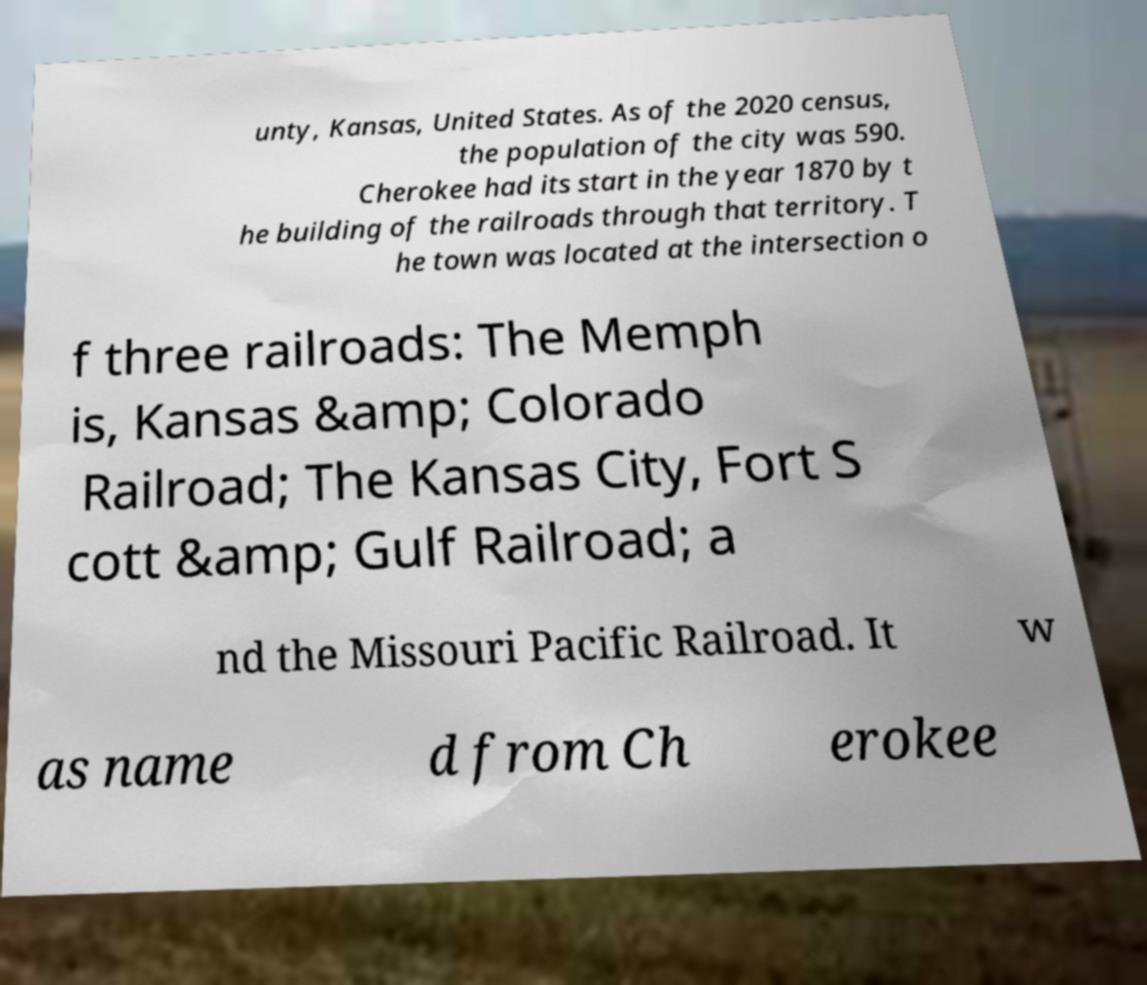I need the written content from this picture converted into text. Can you do that? unty, Kansas, United States. As of the 2020 census, the population of the city was 590. Cherokee had its start in the year 1870 by t he building of the railroads through that territory. T he town was located at the intersection o f three railroads: The Memph is, Kansas &amp; Colorado Railroad; The Kansas City, Fort S cott &amp; Gulf Railroad; a nd the Missouri Pacific Railroad. It w as name d from Ch erokee 